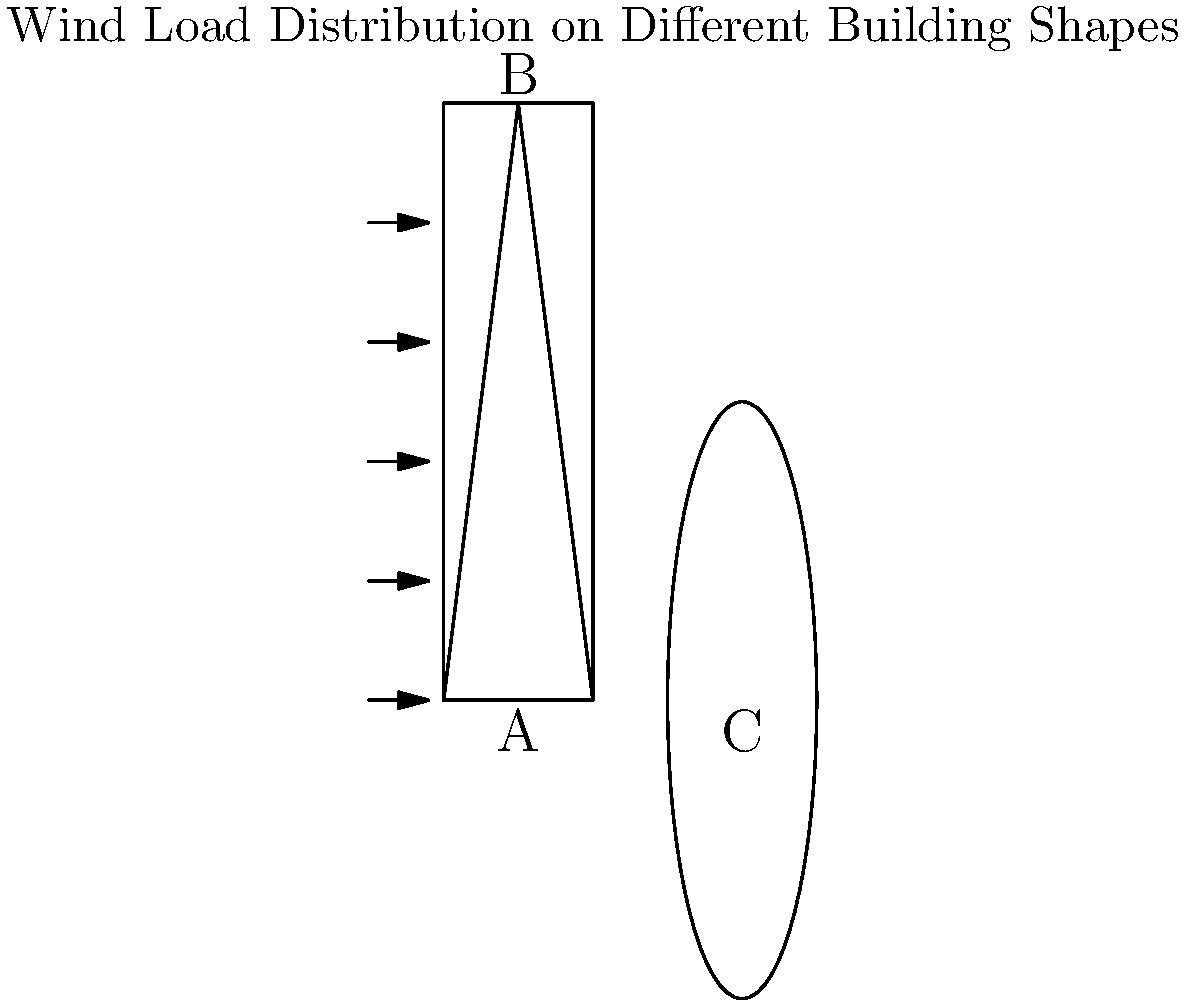In the diagram above, three high-rise buildings with different shapes are shown: a square prism (A), a triangular prism (B), and a cylinder (C). How would you expect the wind load distribution to differ among these shapes, and which shape might be most effective in reducing overall wind load? To understand the wind load distribution on these different building shapes, let's break it down step-by-step:

1. Square Prism (A):
   - Has flat surfaces perpendicular to wind direction
   - Experiences high positive pressure on windward face
   - Creates large negative pressure (suction) on leeward face
   - Generates strong vortices at corners

2. Triangular Prism (B):
   - Sloped windward face deflects wind upward
   - Reduces positive pressure on windward face
   - Still creates negative pressure on leeward face
   - May experience less overall wind load than square prism

3. Cylinder (C):
   - Curved surface allows wind to flow around more smoothly
   - Reduces separation of airflow and vortex formation
   - Experiences more evenly distributed pressure around circumference
   - Generally has lower overall wind load compared to square and triangular prisms

4. Comparison:
   - Square prism likely experiences highest overall wind load
   - Triangular prism may have reduced wind load due to sloped face
   - Cylinder typically has lowest overall wind load due to aerodynamic shape

5. Effectiveness in reducing wind load:
   - Cylinder (C) is most effective in reducing overall wind load
   - Smooth, curved surface minimizes pressure differences and vortex formation
   - Allows for more efficient wind flow around the building

The cylindrical shape (C) would be most effective in reducing overall wind load due to its aerodynamic properties and ability to minimize pressure differences and vortex formation.
Answer: Cylindrical shape (C) is most effective in reducing overall wind load. 